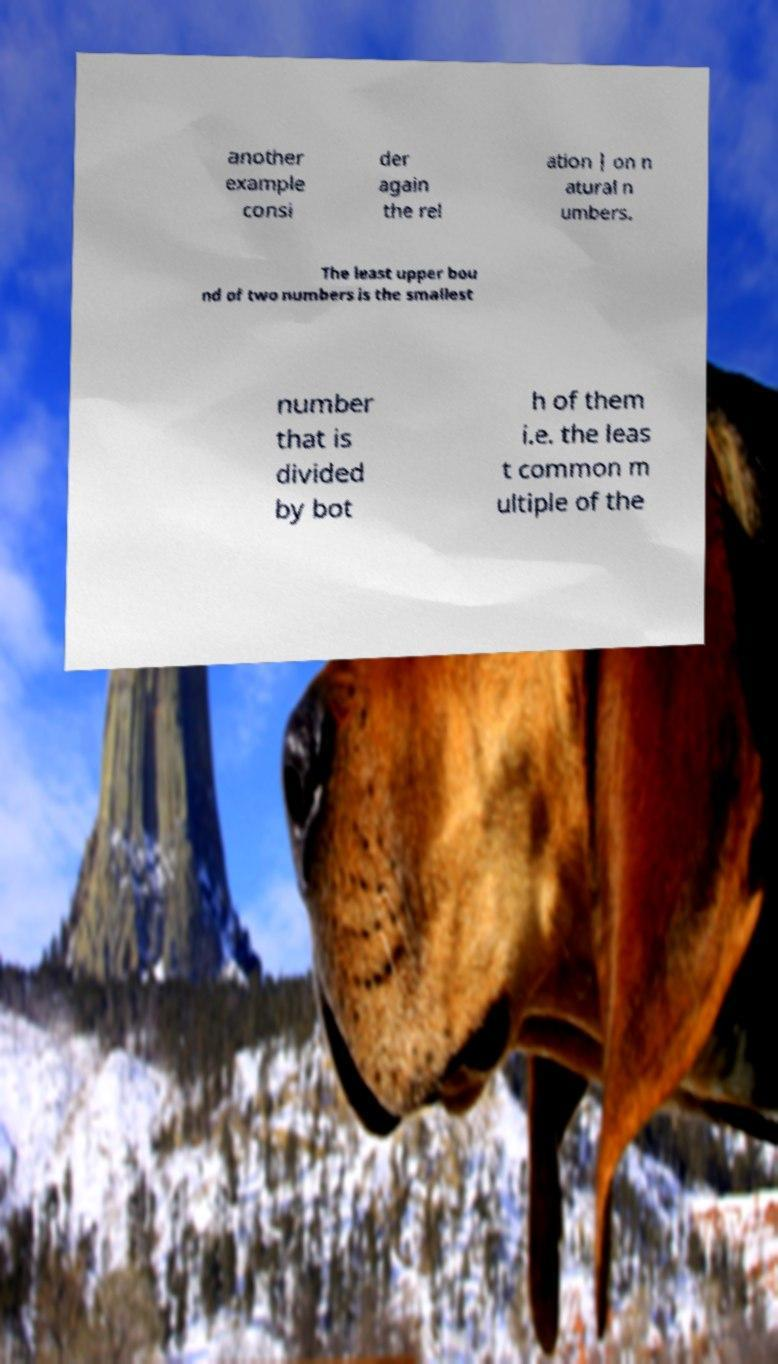For documentation purposes, I need the text within this image transcribed. Could you provide that? another example consi der again the rel ation | on n atural n umbers. The least upper bou nd of two numbers is the smallest number that is divided by bot h of them i.e. the leas t common m ultiple of the 